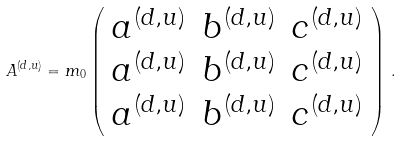Convert formula to latex. <formula><loc_0><loc_0><loc_500><loc_500>A ^ { ( d , u ) } = m _ { 0 } \left ( \begin{array} { c c c } a ^ { ( d , u ) } & b ^ { ( d , u ) } & c ^ { ( d , u ) } \\ a ^ { ( d , u ) } & b ^ { ( d , u ) } & c ^ { ( d , u ) } \\ a ^ { ( d , u ) } & b ^ { ( d , u ) } & c ^ { ( d , u ) } \end{array} \right ) \, .</formula> 